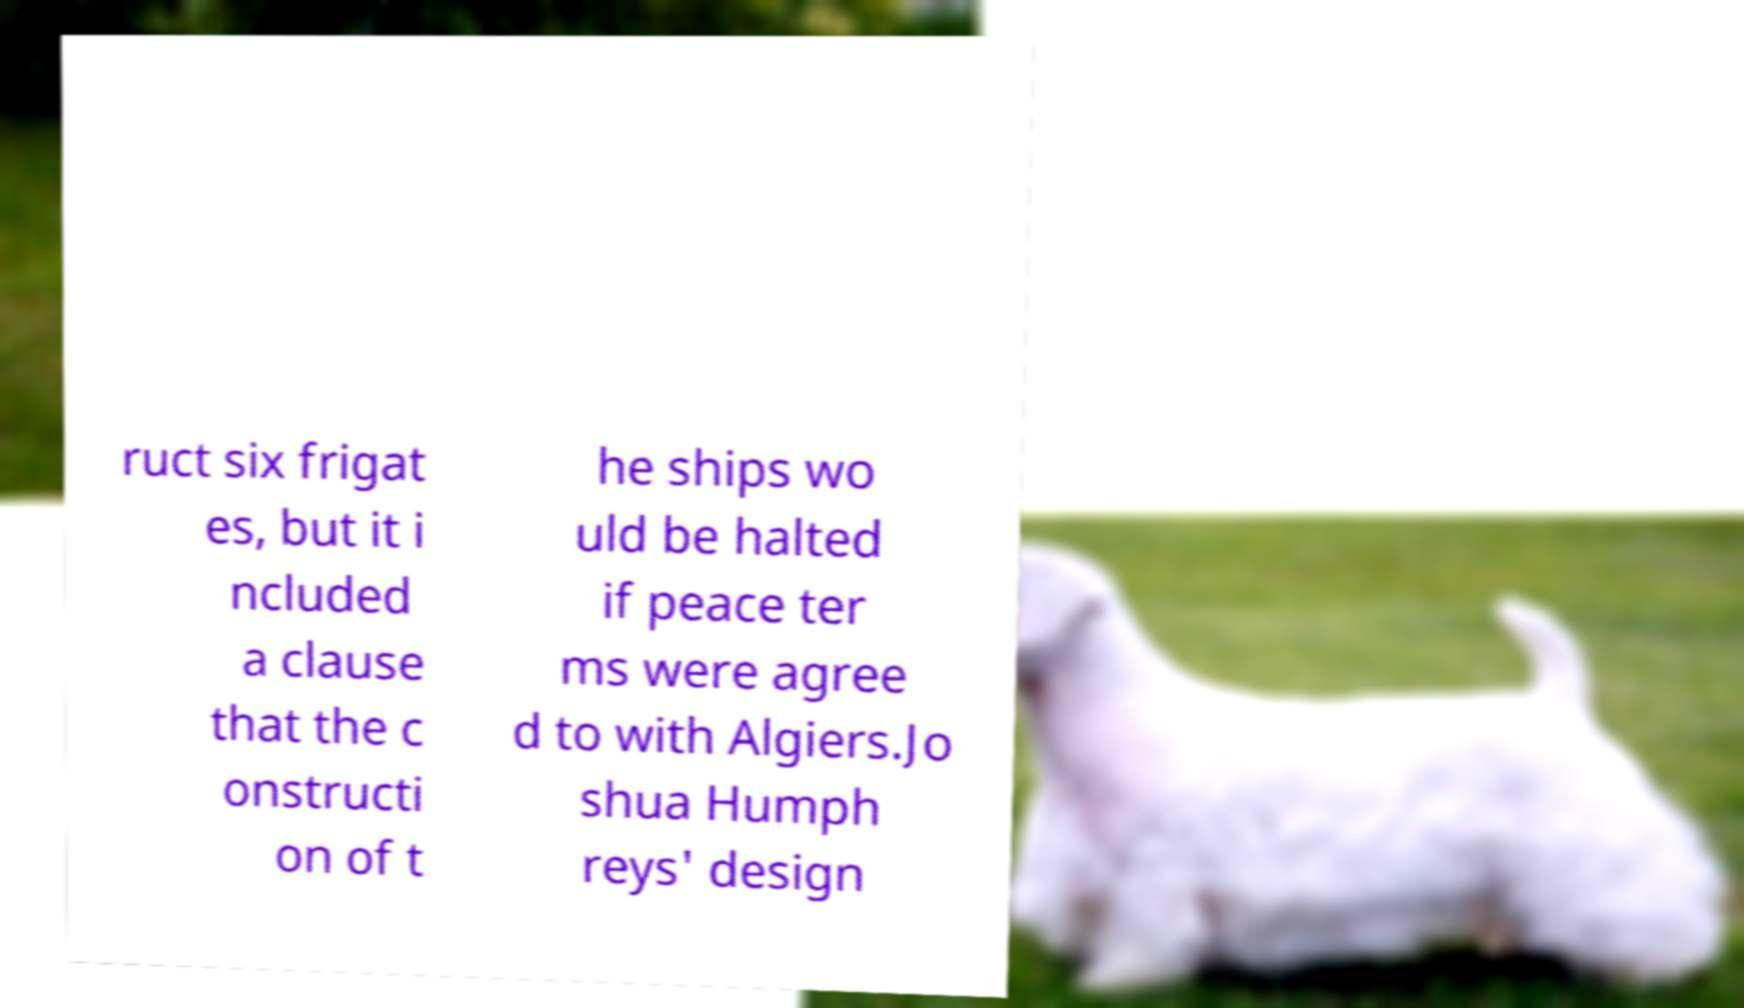For documentation purposes, I need the text within this image transcribed. Could you provide that? ruct six frigat es, but it i ncluded a clause that the c onstructi on of t he ships wo uld be halted if peace ter ms were agree d to with Algiers.Jo shua Humph reys' design 